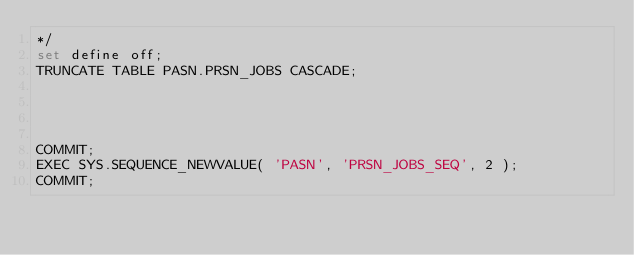Convert code to text. <code><loc_0><loc_0><loc_500><loc_500><_SQL_>*/
set define off;
TRUNCATE TABLE PASN.PRSN_JOBS CASCADE;




COMMIT;
EXEC SYS.SEQUENCE_NEWVALUE( 'PASN', 'PRSN_JOBS_SEQ', 2 );
COMMIT;</code> 